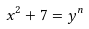Convert formula to latex. <formula><loc_0><loc_0><loc_500><loc_500>x ^ { 2 } + 7 = y ^ { n }</formula> 